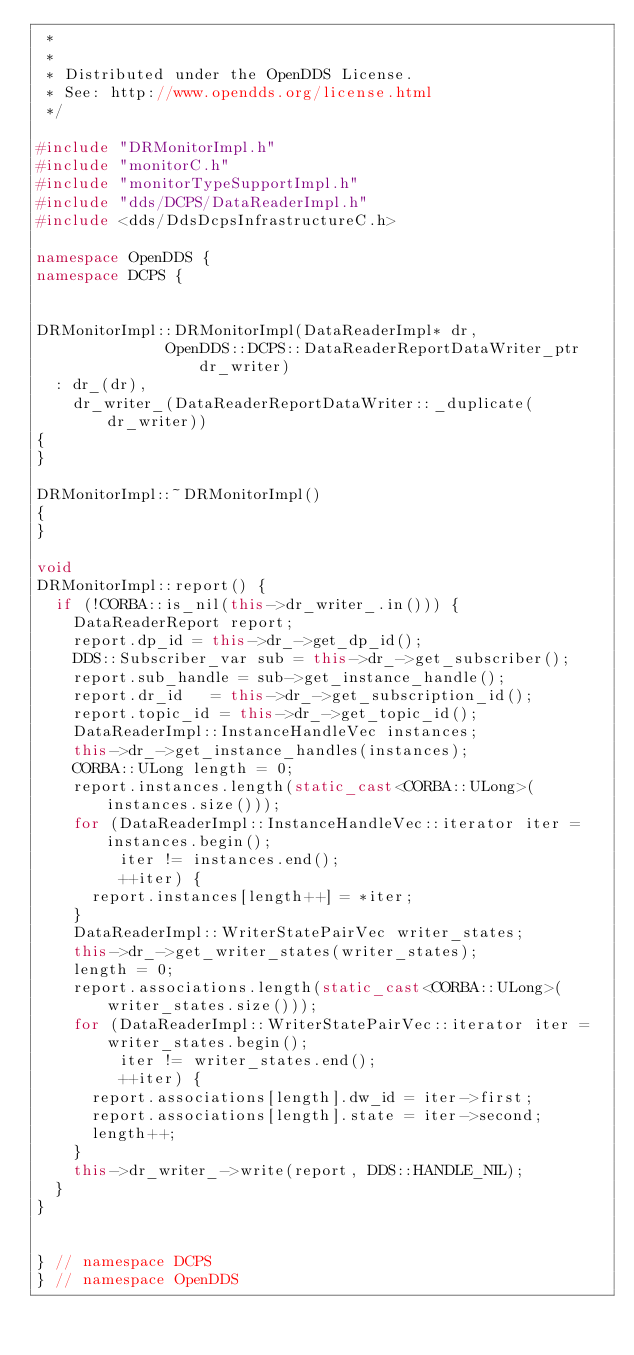<code> <loc_0><loc_0><loc_500><loc_500><_C++_> *
 *
 * Distributed under the OpenDDS License.
 * See: http://www.opendds.org/license.html
 */

#include "DRMonitorImpl.h"
#include "monitorC.h"
#include "monitorTypeSupportImpl.h"
#include "dds/DCPS/DataReaderImpl.h"
#include <dds/DdsDcpsInfrastructureC.h>

namespace OpenDDS {
namespace DCPS {


DRMonitorImpl::DRMonitorImpl(DataReaderImpl* dr,
              OpenDDS::DCPS::DataReaderReportDataWriter_ptr dr_writer)
  : dr_(dr),
    dr_writer_(DataReaderReportDataWriter::_duplicate(dr_writer))
{
}

DRMonitorImpl::~DRMonitorImpl()
{
}

void
DRMonitorImpl::report() {
  if (!CORBA::is_nil(this->dr_writer_.in())) {
    DataReaderReport report;
    report.dp_id = this->dr_->get_dp_id();
    DDS::Subscriber_var sub = this->dr_->get_subscriber();
    report.sub_handle = sub->get_instance_handle();
    report.dr_id   = this->dr_->get_subscription_id();
    report.topic_id = this->dr_->get_topic_id();
    DataReaderImpl::InstanceHandleVec instances;
    this->dr_->get_instance_handles(instances);
    CORBA::ULong length = 0;
    report.instances.length(static_cast<CORBA::ULong>(instances.size()));
    for (DataReaderImpl::InstanceHandleVec::iterator iter = instances.begin();
         iter != instances.end();
         ++iter) {
      report.instances[length++] = *iter;
    }
    DataReaderImpl::WriterStatePairVec writer_states;
    this->dr_->get_writer_states(writer_states);
    length = 0;
    report.associations.length(static_cast<CORBA::ULong>(writer_states.size()));
    for (DataReaderImpl::WriterStatePairVec::iterator iter = writer_states.begin();
         iter != writer_states.end();
         ++iter) {
      report.associations[length].dw_id = iter->first;
      report.associations[length].state = iter->second;
      length++;
    }
    this->dr_writer_->write(report, DDS::HANDLE_NIL);
  }
}


} // namespace DCPS
} // namespace OpenDDS

</code> 